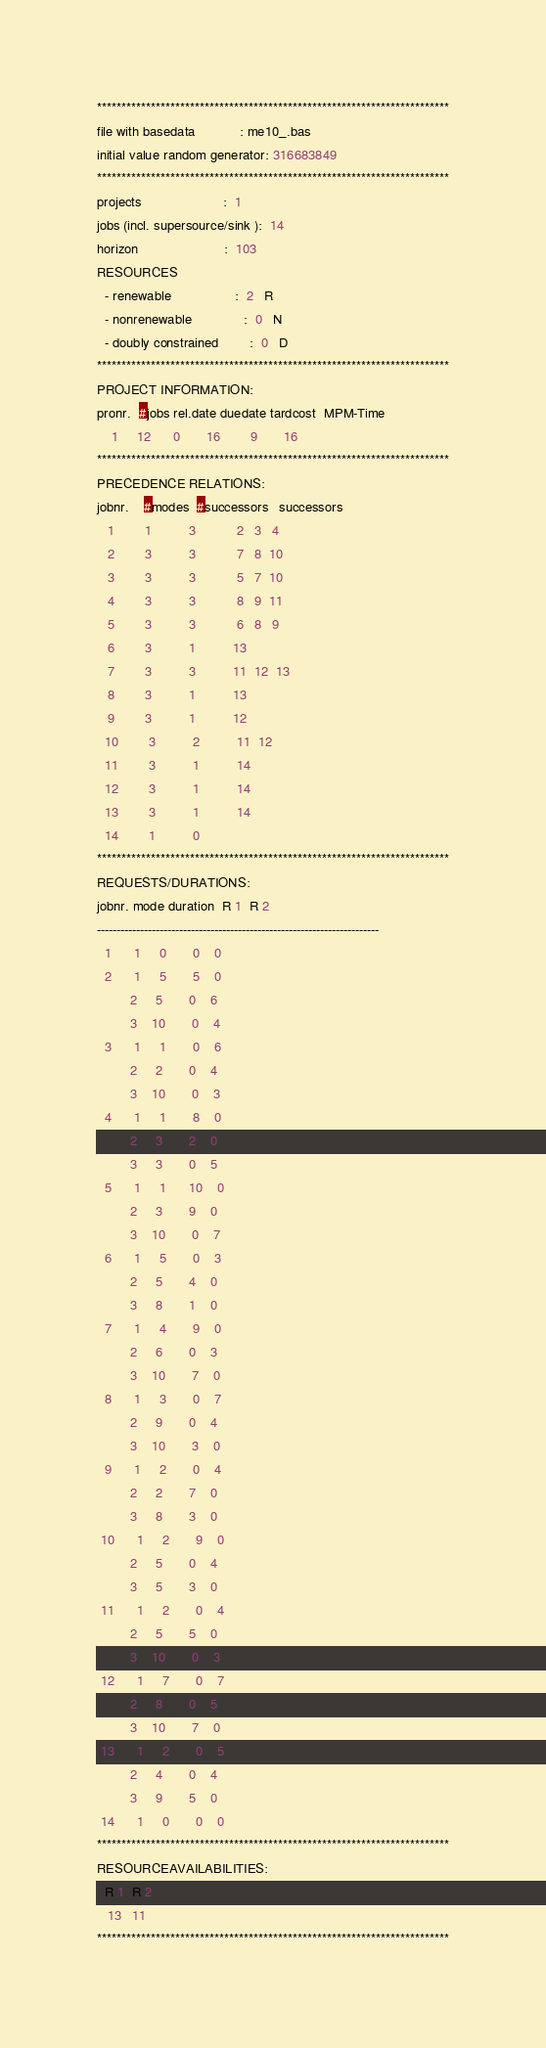Convert code to text. <code><loc_0><loc_0><loc_500><loc_500><_ObjectiveC_>************************************************************************
file with basedata            : me10_.bas
initial value random generator: 316683849
************************************************************************
projects                      :  1
jobs (incl. supersource/sink ):  14
horizon                       :  103
RESOURCES
  - renewable                 :  2   R
  - nonrenewable              :  0   N
  - doubly constrained        :  0   D
************************************************************************
PROJECT INFORMATION:
pronr.  #jobs rel.date duedate tardcost  MPM-Time
    1     12      0       16        9       16
************************************************************************
PRECEDENCE RELATIONS:
jobnr.    #modes  #successors   successors
   1        1          3           2   3   4
   2        3          3           7   8  10
   3        3          3           5   7  10
   4        3          3           8   9  11
   5        3          3           6   8   9
   6        3          1          13
   7        3          3          11  12  13
   8        3          1          13
   9        3          1          12
  10        3          2          11  12
  11        3          1          14
  12        3          1          14
  13        3          1          14
  14        1          0        
************************************************************************
REQUESTS/DURATIONS:
jobnr. mode duration  R 1  R 2
------------------------------------------------------------------------
  1      1     0       0    0
  2      1     5       5    0
         2     5       0    6
         3    10       0    4
  3      1     1       0    6
         2     2       0    4
         3    10       0    3
  4      1     1       8    0
         2     3       2    0
         3     3       0    5
  5      1     1      10    0
         2     3       9    0
         3    10       0    7
  6      1     5       0    3
         2     5       4    0
         3     8       1    0
  7      1     4       9    0
         2     6       0    3
         3    10       7    0
  8      1     3       0    7
         2     9       0    4
         3    10       3    0
  9      1     2       0    4
         2     2       7    0
         3     8       3    0
 10      1     2       9    0
         2     5       0    4
         3     5       3    0
 11      1     2       0    4
         2     5       5    0
         3    10       0    3
 12      1     7       0    7
         2     8       0    5
         3    10       7    0
 13      1     2       0    5
         2     4       0    4
         3     9       5    0
 14      1     0       0    0
************************************************************************
RESOURCEAVAILABILITIES:
  R 1  R 2
   13   11
************************************************************************
</code> 